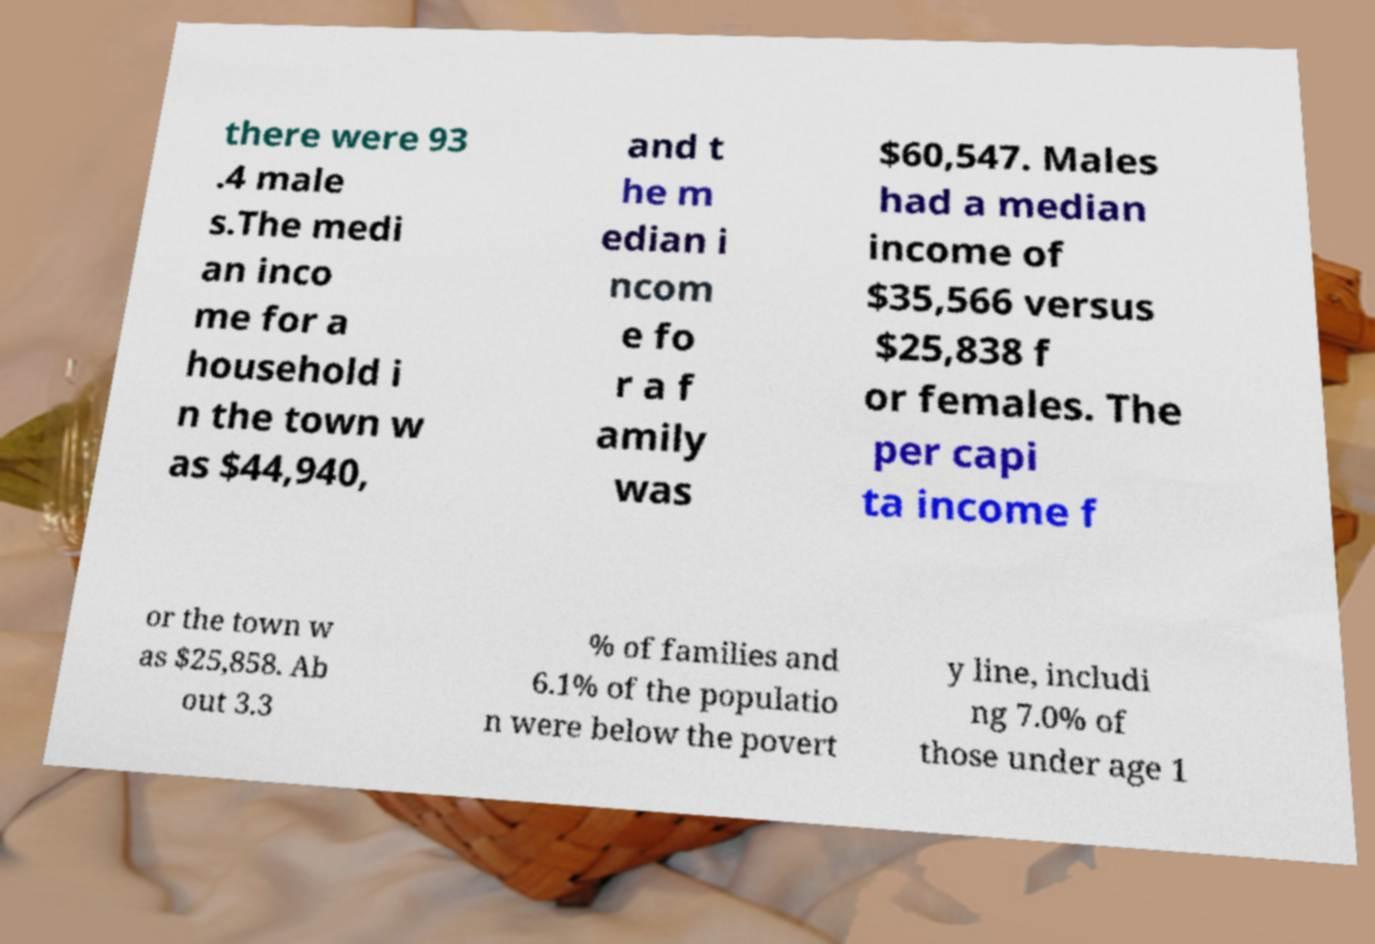Can you accurately transcribe the text from the provided image for me? there were 93 .4 male s.The medi an inco me for a household i n the town w as $44,940, and t he m edian i ncom e fo r a f amily was $60,547. Males had a median income of $35,566 versus $25,838 f or females. The per capi ta income f or the town w as $25,858. Ab out 3.3 % of families and 6.1% of the populatio n were below the povert y line, includi ng 7.0% of those under age 1 